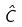Convert formula to latex. <formula><loc_0><loc_0><loc_500><loc_500>\hat { C }</formula> 